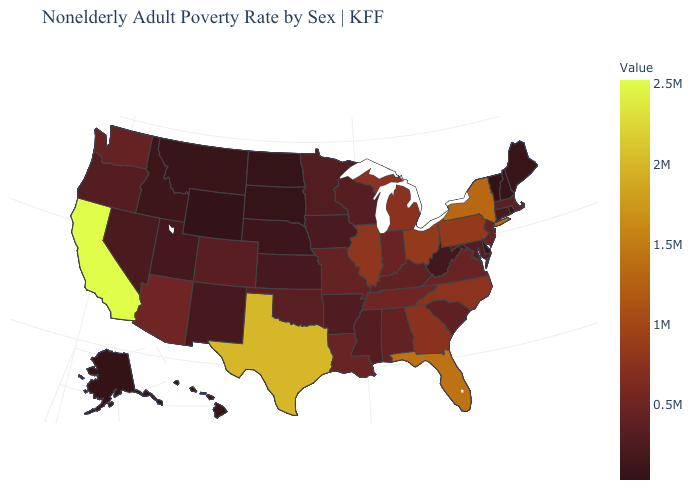Which states have the lowest value in the MidWest?
Concise answer only. South Dakota. Among the states that border Arizona , which have the highest value?
Quick response, please. California. Does Maine have the highest value in the USA?
Quick response, please. No. Does South Carolina have the highest value in the USA?
Give a very brief answer. No. Does Michigan have a higher value than Texas?
Short answer required. No. 